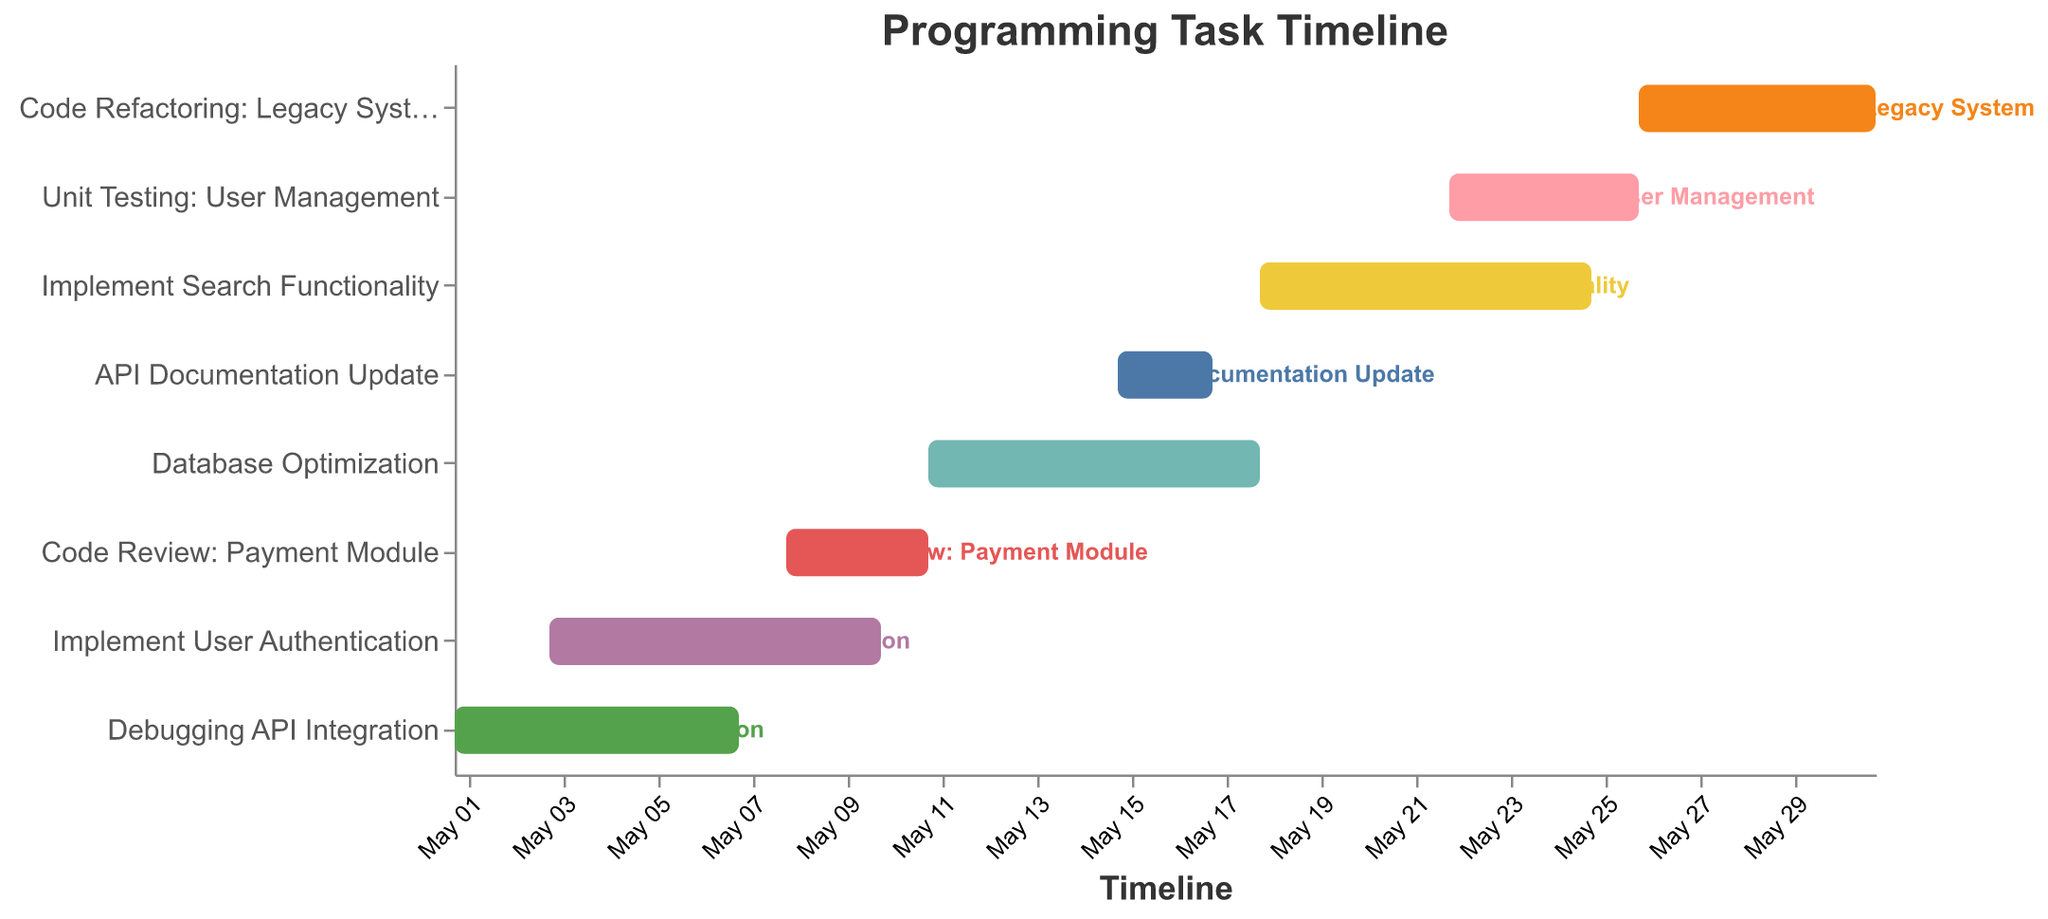Which task was completed first? To determine the first task completed, look for the task with the earliest end date. "Debugging API Integration" ended on May 7, which is the earliest end date.
Answer: Debugging API Integration What time span does "Unit Testing: User Management" cover? Look for the start and end dates of "Unit Testing: User Management." The task starts on May 22 and ends on May 26.
Answer: May 22 - May 26 How many tasks had overlapping time periods with "Implement User Authentication"? Identify tasks that overlap with "Implement User Authentication" (May 3 - May 10). These are: "Debugging API Integration" (May 1 - May 7), and "Code Review: Payment Module" (May 8 - May 11).
Answer: 2 tasks Which task took the longest to complete? Determine the duration for each task by counting the days between the start and end dates. "Implement Search Functionality" lasts from May 18 to May 25, which is 8 days—the longest.
Answer: Implement Search Functionality During which dates were the maximum number of tasks handled simultaneously? Examine the time periods of the tasks and find the interval with the most overlaps. May 15 - May 17 has three overlapping tasks: "Database Optimization," "API Documentation Update," and "Implement Search Functionality."
Answer: May 15 - May 17 Which task started immediately after "Database Optimization"? "Database Optimization" ends on May 18. The next task that starts exactly after this ends is "Implement Search Functionality," which also starts on May 18.
Answer: Implement Search Functionality How many days were spent on "Code Refactoring: Legacy System"? Calculate the days between the start and end dates of the task. "Code Refactoring: Legacy System" starts on May 26 and ends on May 31. The duration is 6 days.
Answer: 6 days 